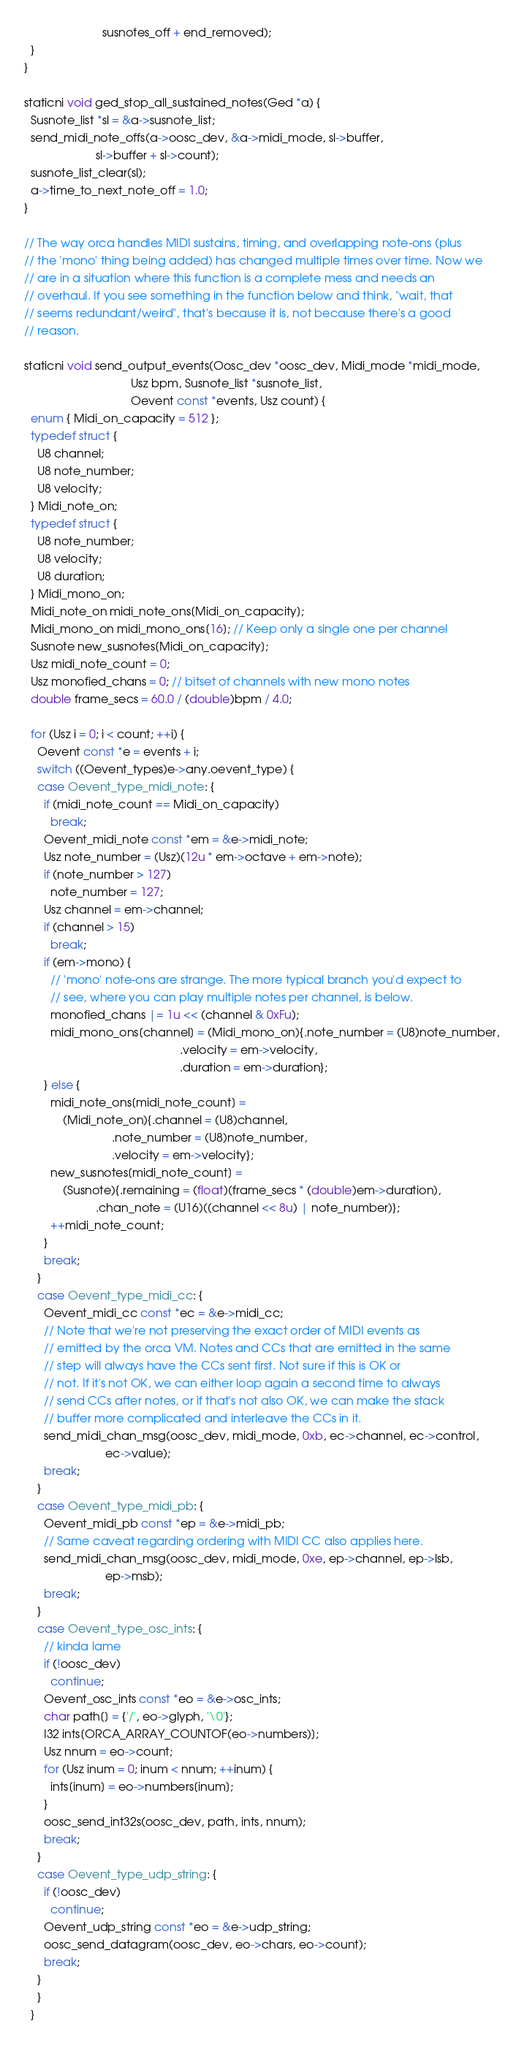<code> <loc_0><loc_0><loc_500><loc_500><_C_>                        susnotes_off + end_removed);
  }
}

staticni void ged_stop_all_sustained_notes(Ged *a) {
  Susnote_list *sl = &a->susnote_list;
  send_midi_note_offs(a->oosc_dev, &a->midi_mode, sl->buffer,
                      sl->buffer + sl->count);
  susnote_list_clear(sl);
  a->time_to_next_note_off = 1.0;
}

// The way orca handles MIDI sustains, timing, and overlapping note-ons (plus
// the 'mono' thing being added) has changed multiple times over time. Now we
// are in a situation where this function is a complete mess and needs an
// overhaul. If you see something in the function below and think, "wait, that
// seems redundant/weird", that's because it is, not because there's a good
// reason.

staticni void send_output_events(Oosc_dev *oosc_dev, Midi_mode *midi_mode,
                                 Usz bpm, Susnote_list *susnote_list,
                                 Oevent const *events, Usz count) {
  enum { Midi_on_capacity = 512 };
  typedef struct {
    U8 channel;
    U8 note_number;
    U8 velocity;
  } Midi_note_on;
  typedef struct {
    U8 note_number;
    U8 velocity;
    U8 duration;
  } Midi_mono_on;
  Midi_note_on midi_note_ons[Midi_on_capacity];
  Midi_mono_on midi_mono_ons[16]; // Keep only a single one per channel
  Susnote new_susnotes[Midi_on_capacity];
  Usz midi_note_count = 0;
  Usz monofied_chans = 0; // bitset of channels with new mono notes
  double frame_secs = 60.0 / (double)bpm / 4.0;

  for (Usz i = 0; i < count; ++i) {
    Oevent const *e = events + i;
    switch ((Oevent_types)e->any.oevent_type) {
    case Oevent_type_midi_note: {
      if (midi_note_count == Midi_on_capacity)
        break;
      Oevent_midi_note const *em = &e->midi_note;
      Usz note_number = (Usz)(12u * em->octave + em->note);
      if (note_number > 127)
        note_number = 127;
      Usz channel = em->channel;
      if (channel > 15)
        break;
      if (em->mono) {
        // 'mono' note-ons are strange. The more typical branch you'd expect to
        // see, where you can play multiple notes per channel, is below.
        monofied_chans |= 1u << (channel & 0xFu);
        midi_mono_ons[channel] = (Midi_mono_on){.note_number = (U8)note_number,
                                                .velocity = em->velocity,
                                                .duration = em->duration};
      } else {
        midi_note_ons[midi_note_count] =
            (Midi_note_on){.channel = (U8)channel,
                           .note_number = (U8)note_number,
                           .velocity = em->velocity};
        new_susnotes[midi_note_count] =
            (Susnote){.remaining = (float)(frame_secs * (double)em->duration),
                      .chan_note = (U16)((channel << 8u) | note_number)};
        ++midi_note_count;
      }
      break;
    }
    case Oevent_type_midi_cc: {
      Oevent_midi_cc const *ec = &e->midi_cc;
      // Note that we're not preserving the exact order of MIDI events as
      // emitted by the orca VM. Notes and CCs that are emitted in the same
      // step will always have the CCs sent first. Not sure if this is OK or
      // not. If it's not OK, we can either loop again a second time to always
      // send CCs after notes, or if that's not also OK, we can make the stack
      // buffer more complicated and interleave the CCs in it.
      send_midi_chan_msg(oosc_dev, midi_mode, 0xb, ec->channel, ec->control,
                         ec->value);
      break;
    }
    case Oevent_type_midi_pb: {
      Oevent_midi_pb const *ep = &e->midi_pb;
      // Same caveat regarding ordering with MIDI CC also applies here.
      send_midi_chan_msg(oosc_dev, midi_mode, 0xe, ep->channel, ep->lsb,
                         ep->msb);
      break;
    }
    case Oevent_type_osc_ints: {
      // kinda lame
      if (!oosc_dev)
        continue;
      Oevent_osc_ints const *eo = &e->osc_ints;
      char path[] = {'/', eo->glyph, '\0'};
      I32 ints[ORCA_ARRAY_COUNTOF(eo->numbers)];
      Usz nnum = eo->count;
      for (Usz inum = 0; inum < nnum; ++inum) {
        ints[inum] = eo->numbers[inum];
      }
      oosc_send_int32s(oosc_dev, path, ints, nnum);
      break;
    }
    case Oevent_type_udp_string: {
      if (!oosc_dev)
        continue;
      Oevent_udp_string const *eo = &e->udp_string;
      oosc_send_datagram(oosc_dev, eo->chars, eo->count);
      break;
    }
    }
  }
</code> 